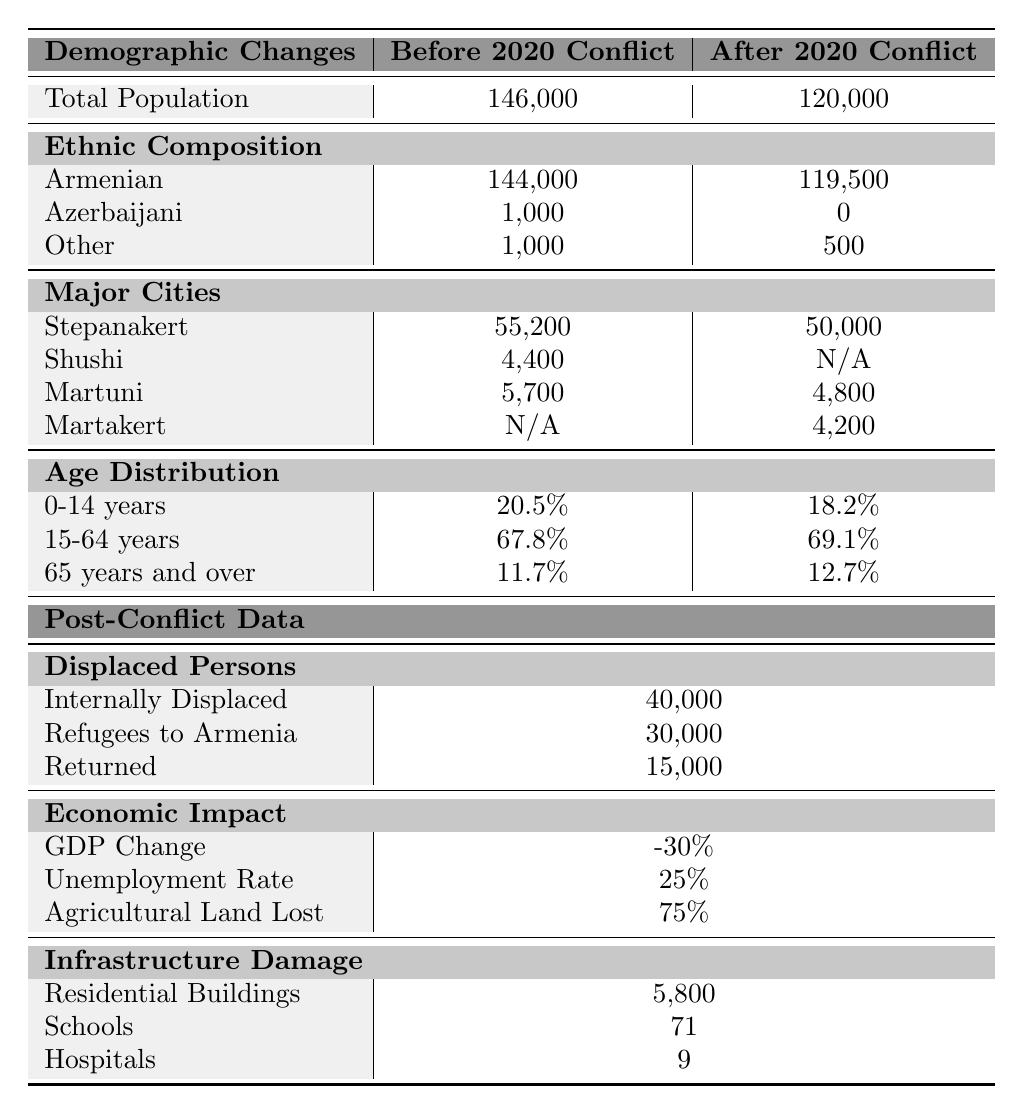What was the total population of Nagorno-Karabakh before the 2020 conflict? The table states that the total population before the 2020 conflict was listed as 146,000. Therefore, we can directly find this value in the table.
Answer: 146,000 What was the ethnic breakdown of the population after the 2020 conflict? The table provides the ethnic composition after the 2020 conflict, with 119,500 Armenians, 0 Azerbaijanis, and 500 Others. We can read these values directly from the table.
Answer: Armenians: 119,500; Azerbaijanis: 0; Others: 500 How many internally displaced persons were reported? According to the table, there were 40,000 internally displaced persons after the conflict, as listed in the section on Displaced Persons.
Answer: 40,000 What is the percentage change in total population from before to after the conflict? The total population before the conflict was 146,000 and after was 120,000. To find the change: 146,000 - 120,000 = 26,000. The percentage change is thus (26,000 / 146,000) * 100 = 17.8%.
Answer: 17.8% Did the percentage of the population aged 15-64 years increase or decrease after the conflict? The percentage of people aged 15-64 years was 67.8% before the conflict and increased to 69.1% afterward. Therefore, we can say that it increased.
Answer: Increased How many major cities are listed before and after the 2020 conflict? Before the conflict, there were three cities listed (Stepanakert, Shushi, and Martuni), while after the conflict, there were four cities listed (Stepanakert, Martuni, and Martakert). Counting the major cities provides us with these totals.
Answer: Before: 3; After: 4 What was the GDP change after the conflict? The table shows that the GDP change after the conflict was -30%. We can directly reference this value in the Economic Impact section of the table.
Answer: -30% Was the population of Stepanakert higher before or after the conflict? The population of Stepanakert was 55,200 before the conflict and 50,000 afterward. Comparing these two numbers shows that it was higher before the conflict.
Answer: Higher before What is the total number of children (0-14 years) before and after the conflict? According to the table, the percentage of children aged 0-14 years was 20.5% before and 18.2% after. To find the actual number of children: Before: 20.5% of 146,000 = 29,930; After: 18.2% of 120,000 = 21,840. Thus, we see the total number decreased after the conflict.
Answer: Before: 29,930; After: 21,840 What was the loss of agricultural land as a percentage after the 2020 conflict? The table states that 75% of agricultural land was lost as reported in the Economic Impact section. This is a direct reading from the table.
Answer: 75% 